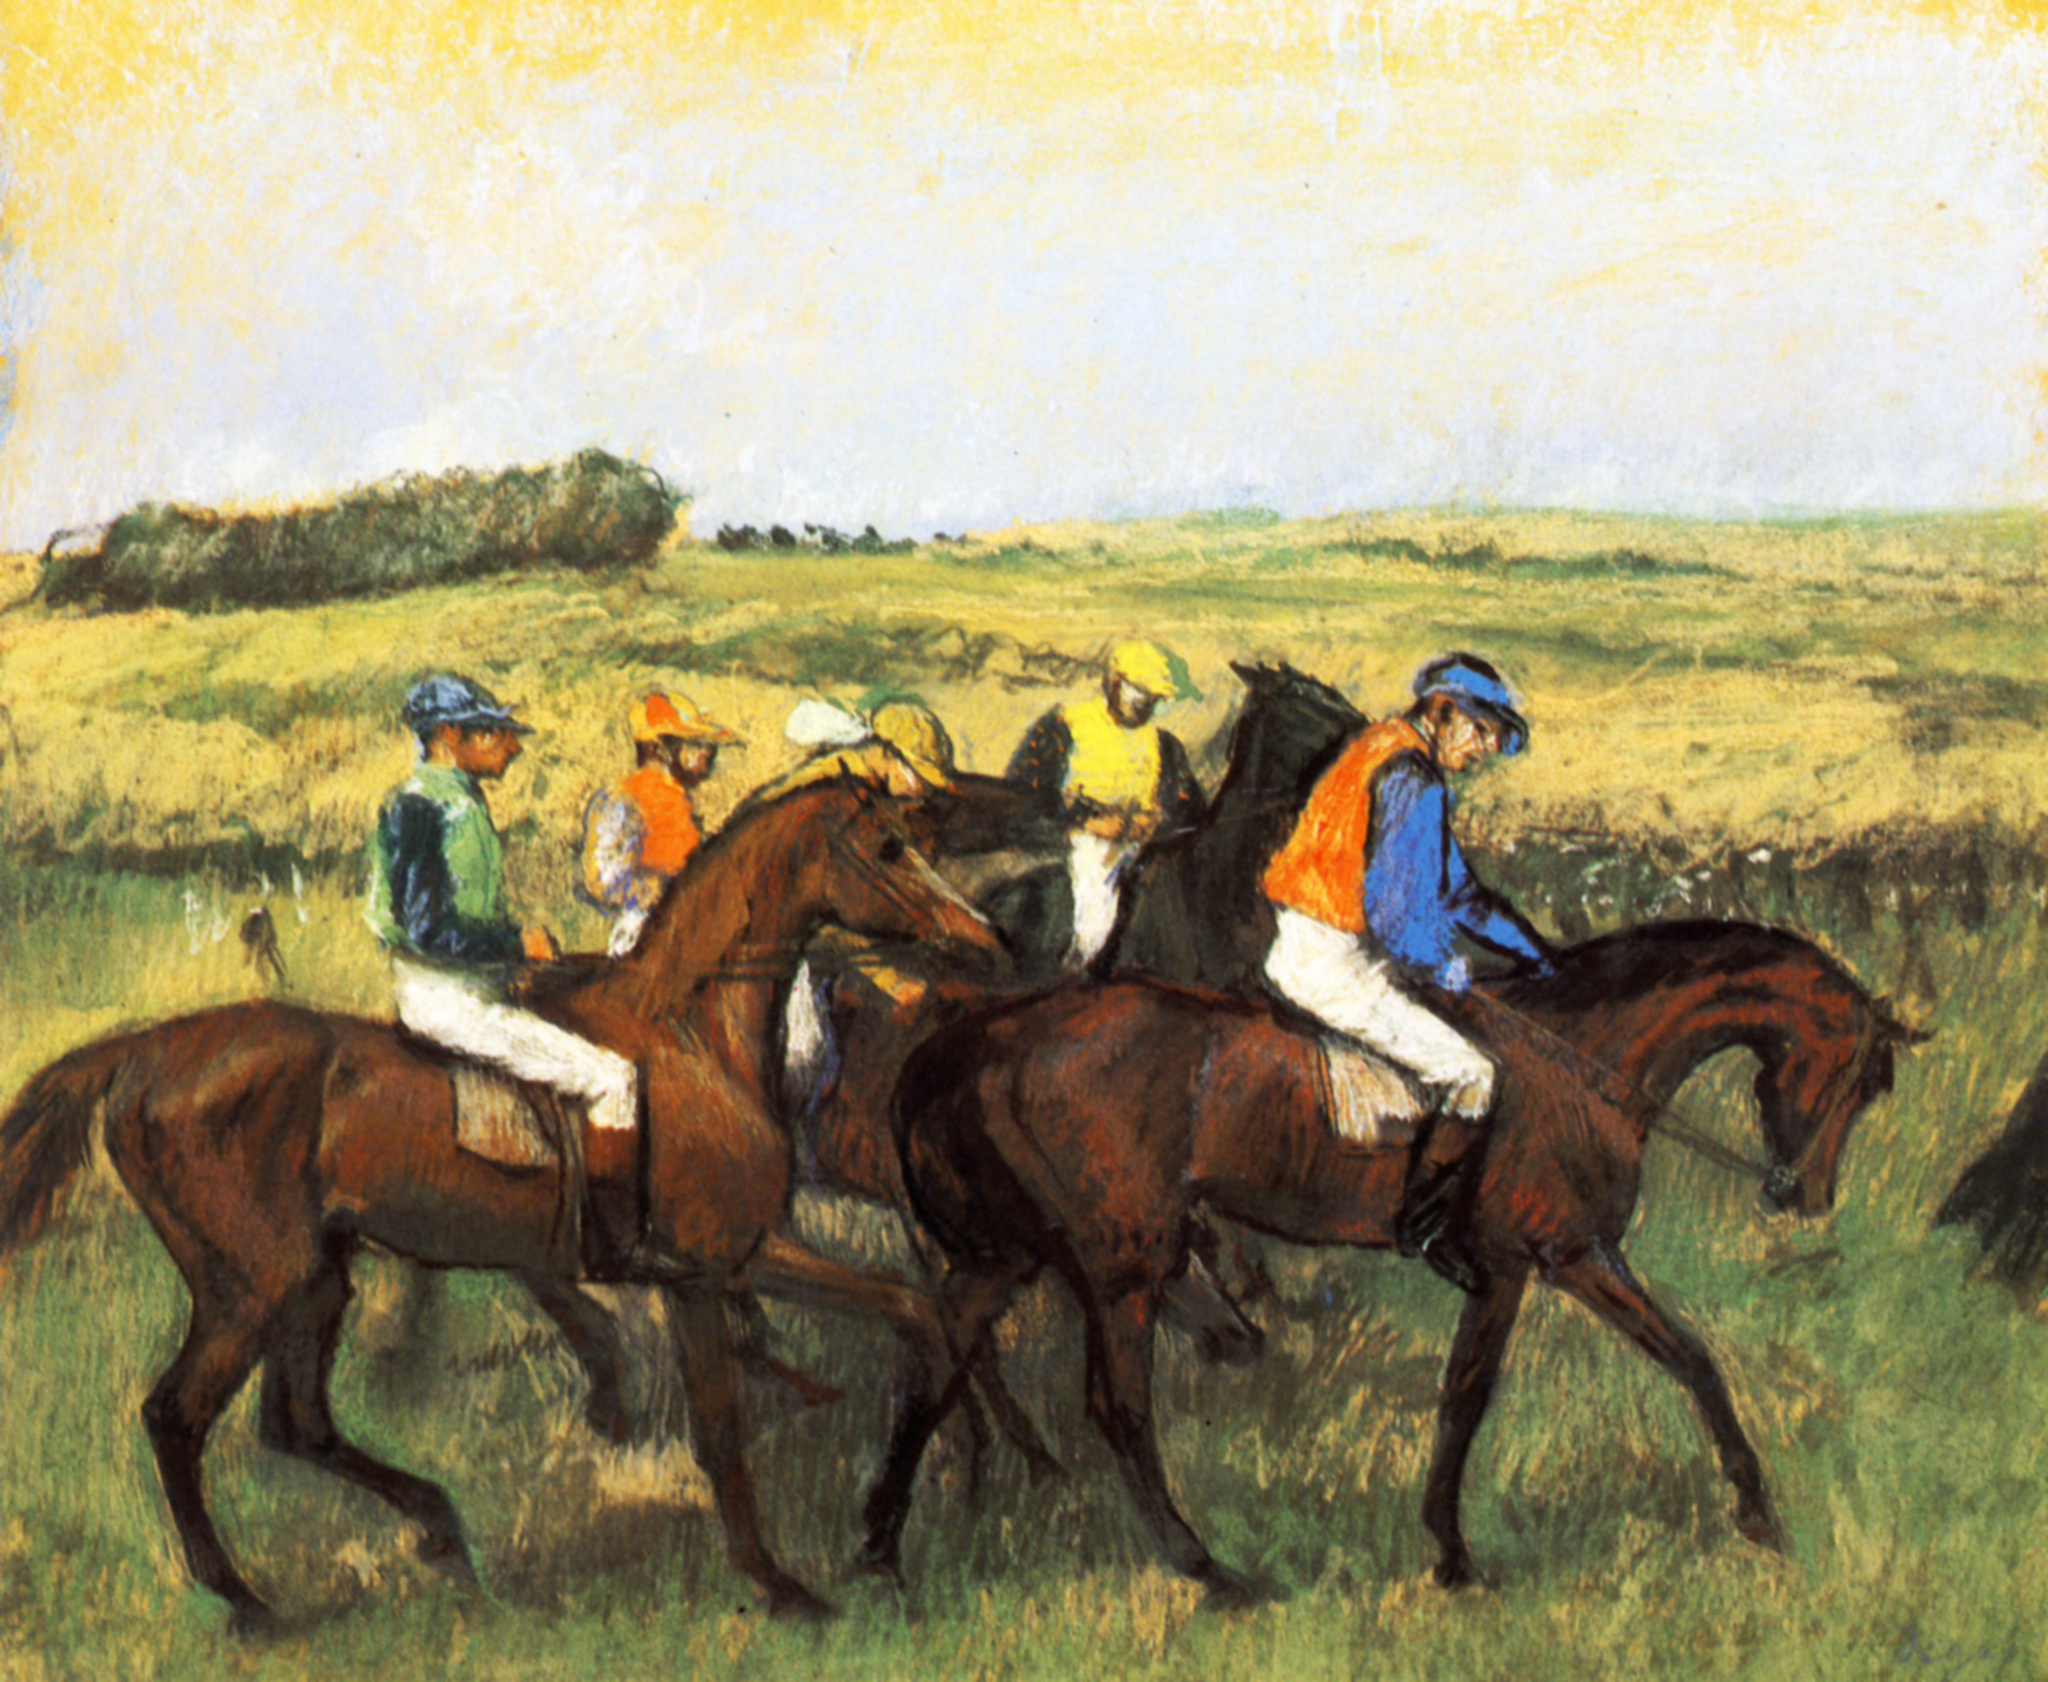What are the key elements in this picture? The image features an expressionist-style horse race scene with jockeys in mid-gallop, intensely competing. Each jockey is distinctively dressed in brightly colored racing silks, juxtaposed against the natural hues of the horses and the serene, grassy backdrop. The painting captures a strong sense of motion and dynamic energy through its visible brushstrokes and texture variations, characteristic of the Expressionist movement. The sky is minimally detailed with soft clouds, focusing attention on the racers' vibrant confrontation. This artwork effectively conveys the thrill and vitality of an equestrian race through its composition and stylistic choices. 